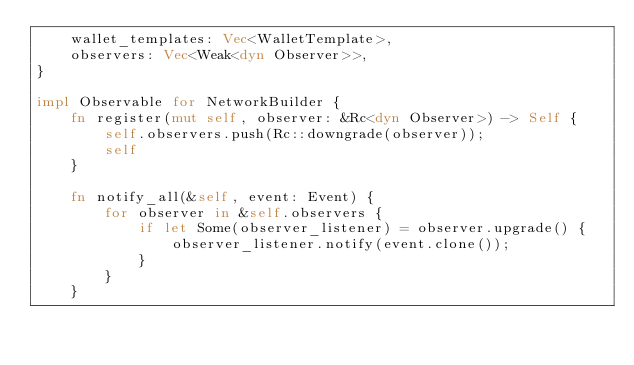Convert code to text. <code><loc_0><loc_0><loc_500><loc_500><_Rust_>    wallet_templates: Vec<WalletTemplate>,
    observers: Vec<Weak<dyn Observer>>,
}

impl Observable for NetworkBuilder {
    fn register(mut self, observer: &Rc<dyn Observer>) -> Self {
        self.observers.push(Rc::downgrade(observer));
        self
    }

    fn notify_all(&self, event: Event) {
        for observer in &self.observers {
            if let Some(observer_listener) = observer.upgrade() {
                observer_listener.notify(event.clone());
            }
        }
    }
</code> 